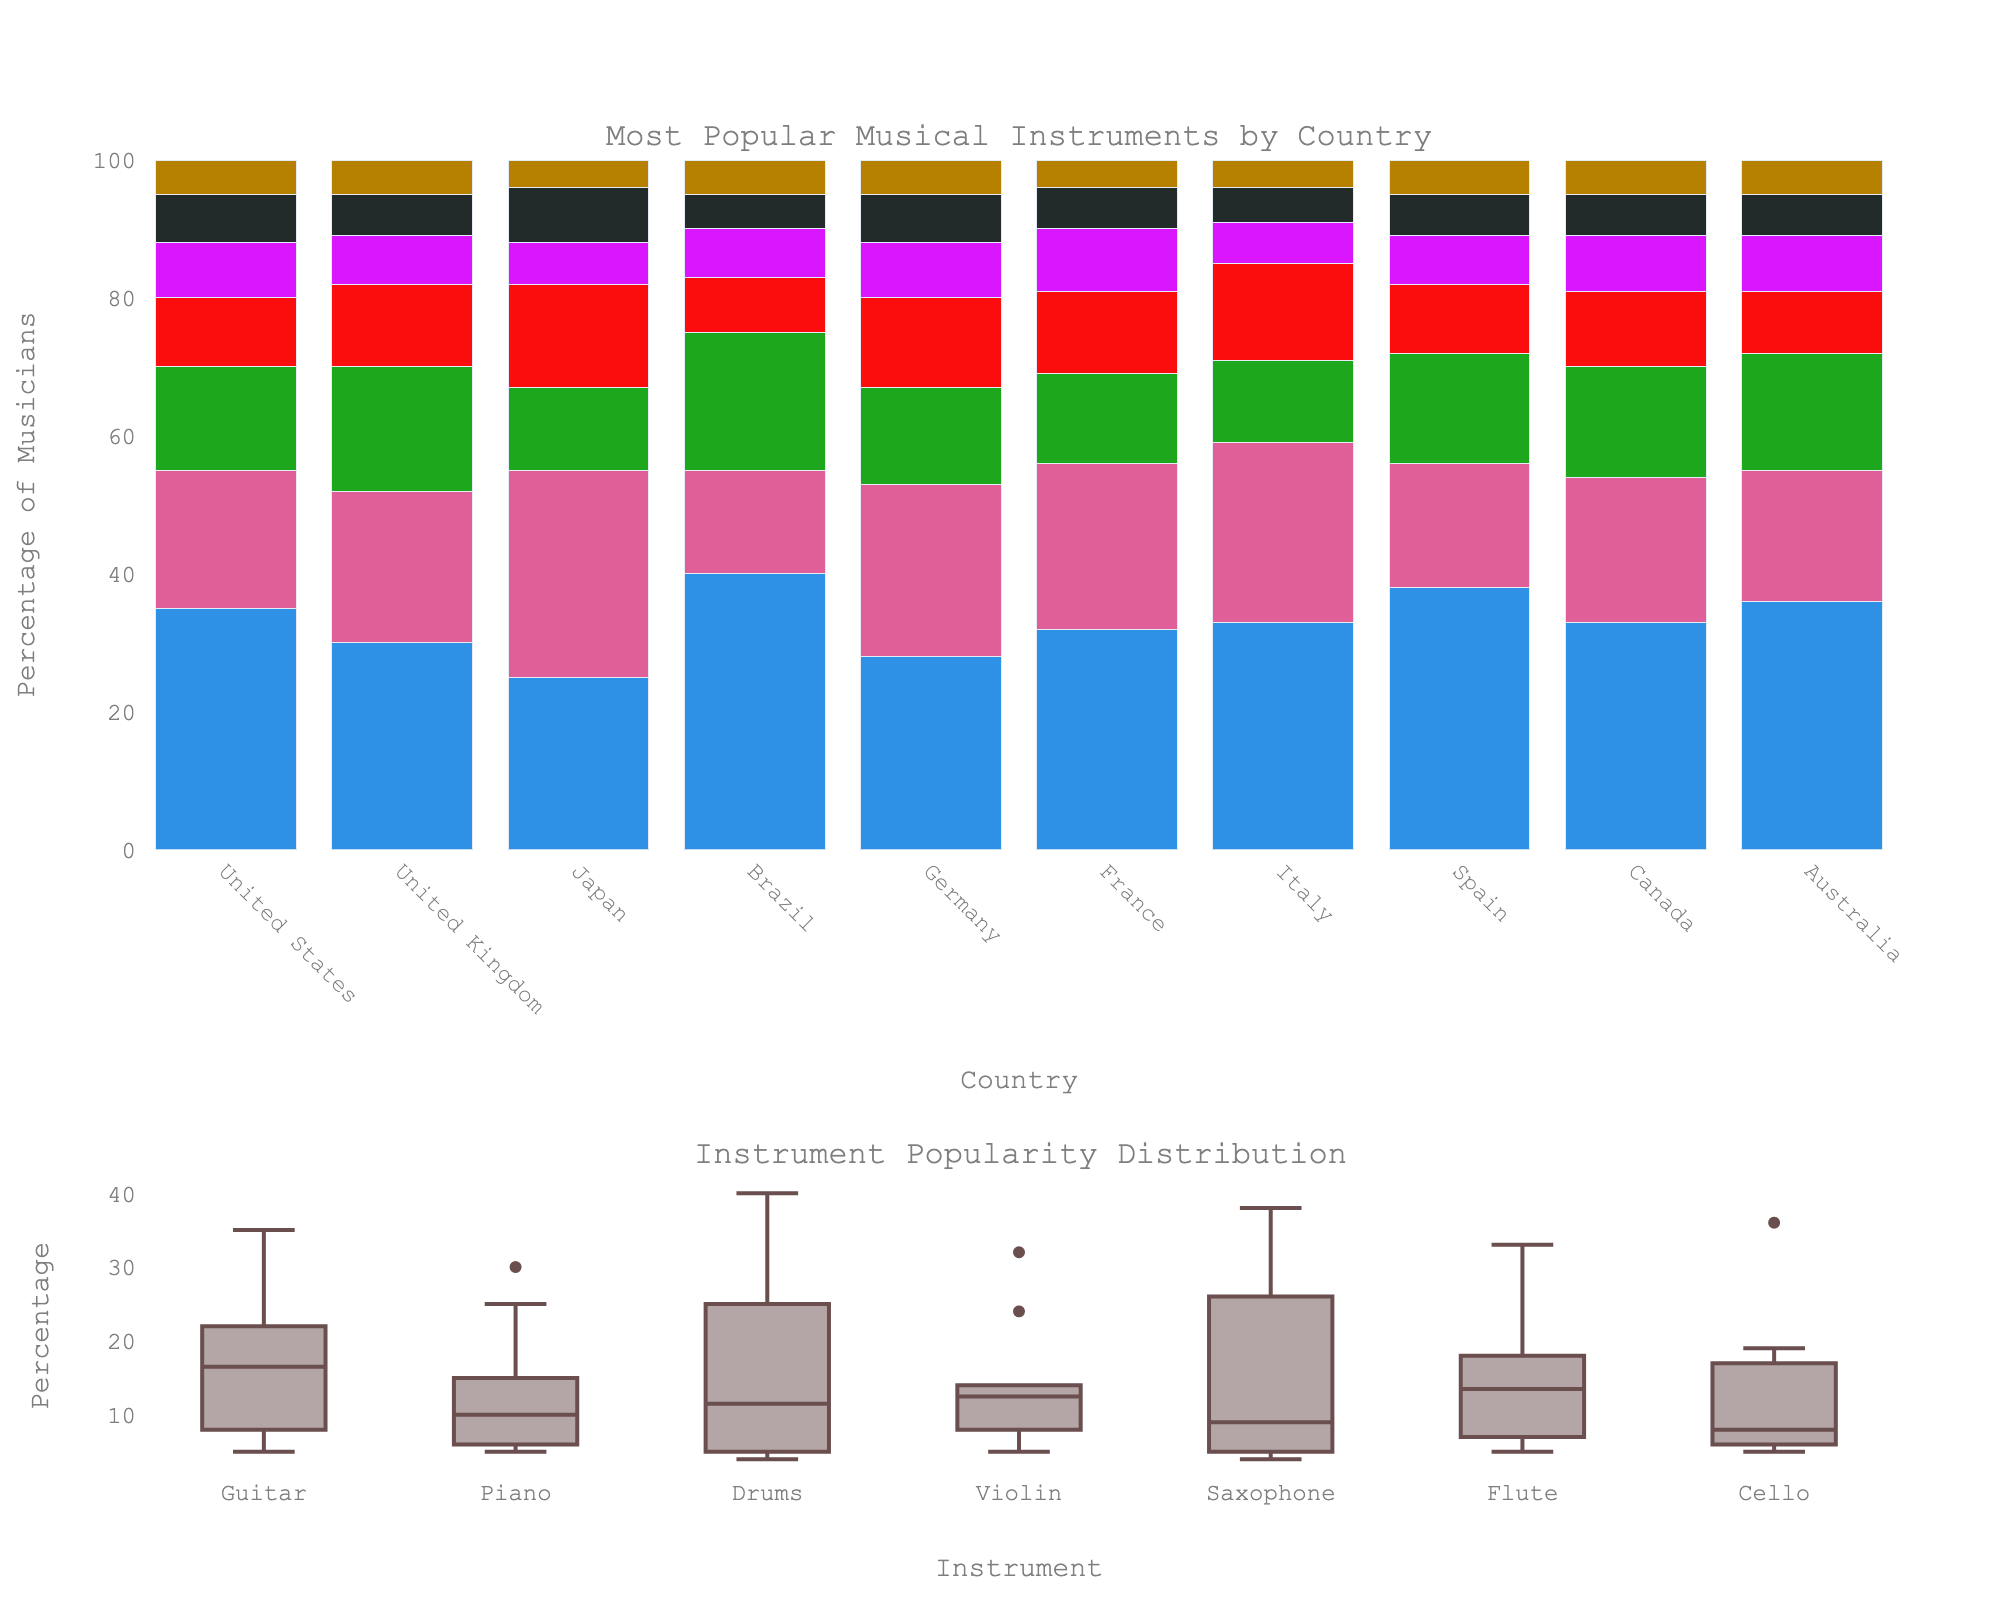Which country has the highest percentage of musicians playing the guitar? Look at the bar heights for the guitar category across all countries. The highest bar corresponds to Brazil.
Answer: Brazil Which instrument is the second most popular in the United States? Check the bar heights for the United States. After the highest bar (guitar at 35%), the next highest is piano at 20%.
Answer: Piano Is the violin more popular in Japan or Australia? Compare the bar heights for the violin category between Japan and Australia. Japan has a higher bar (15%) compared to Australia (9%).
Answer: Japan What is the total percentage of musicians playing the flute in France and Germany? Sum the flute percentages for France (6%) and Germany (7%). 6% + 7% = 13%.
Answer: 13% Which instrument has the lowest overall popularity across all countries? Look at the box plot in the second subchart that shows the distribution of instrument popularity. The instrument with the lowest median value should be the cello.
Answer: Cello How much more popular is the guitar in Brazil compared to Japan? Subtract the percentage of guitar players in Japan (25%) from those in Brazil (40%). 40% - 25% = 15%.
Answer: 15% Which country has the highest percentage of musicians playing the drums? Check the bar heights for the drums category across all countries. The highest bar is for Brazil at 20%.
Answer: Brazil Among the instruments listed, which one is most equally distributed in terms of popularity across countries? Look at the box plot; the instrument with the narrowest interquartile range (IQR) would be the most equally distributed. Both the cello and saxophone have narrow distributions, but the saxophone appears slightly more consistent.
Answer: Saxophone How many countries have piano as the most popular instrument? Check each country's highest percentage bar; piano is the most popular in two countries (Japan 30% and Italy 26%).
Answer: 2 What is the average percentage of musicians playing the guitar across all countries? Sum the guitar percentages across all countries and divide by the number of countries: (35 + 30 + 25 + 40 + 28 + 32 + 33 + 38 + 33 + 36) / 10 = 330 / 10 = 33%.
Answer: 33% 